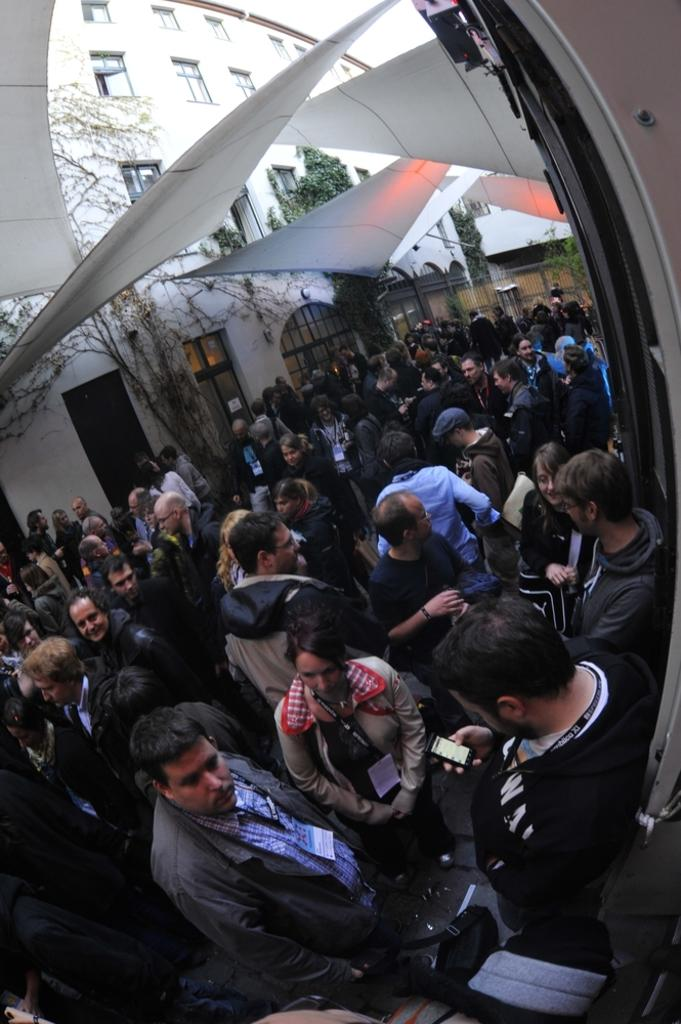What is happening in the image? There are people standing in the image. What can be seen in the background of the image? There is a white color building and trees in the background of the image. What is the name of the queen who is holding the jar in the image? There is no queen or jar present in the image. 